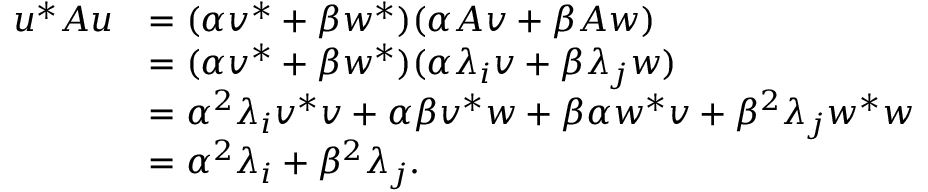Convert formula to latex. <formula><loc_0><loc_0><loc_500><loc_500>\begin{array} { r l } { u ^ { \ast } A u } & { = ( \alpha v ^ { \ast } + \beta w ^ { \ast } ) ( \alpha A v + \beta A w ) } \\ & { = ( \alpha v ^ { * } + \beta w ^ { * } ) ( \alpha \lambda _ { i } v + \beta \lambda _ { j } w ) } \\ & { = \alpha ^ { 2 } \lambda _ { i } v ^ { \ast } v + \alpha \beta v ^ { \ast } w + \beta \alpha w ^ { \ast } v + \beta ^ { 2 } \lambda _ { j } w ^ { \ast } w } \\ & { = \alpha ^ { 2 } \lambda _ { i } + \beta ^ { 2 } \lambda _ { j } . } \end{array}</formula> 